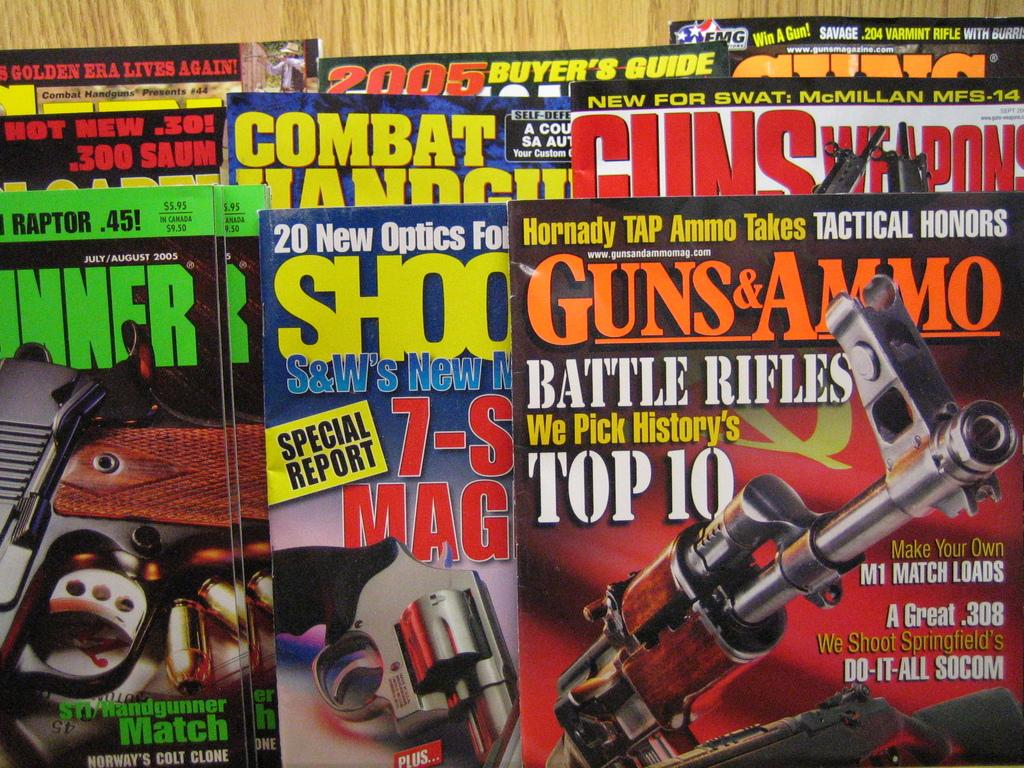<image>
Render a clear and concise summary of the photo. several guns and shooting magazines are laying together 